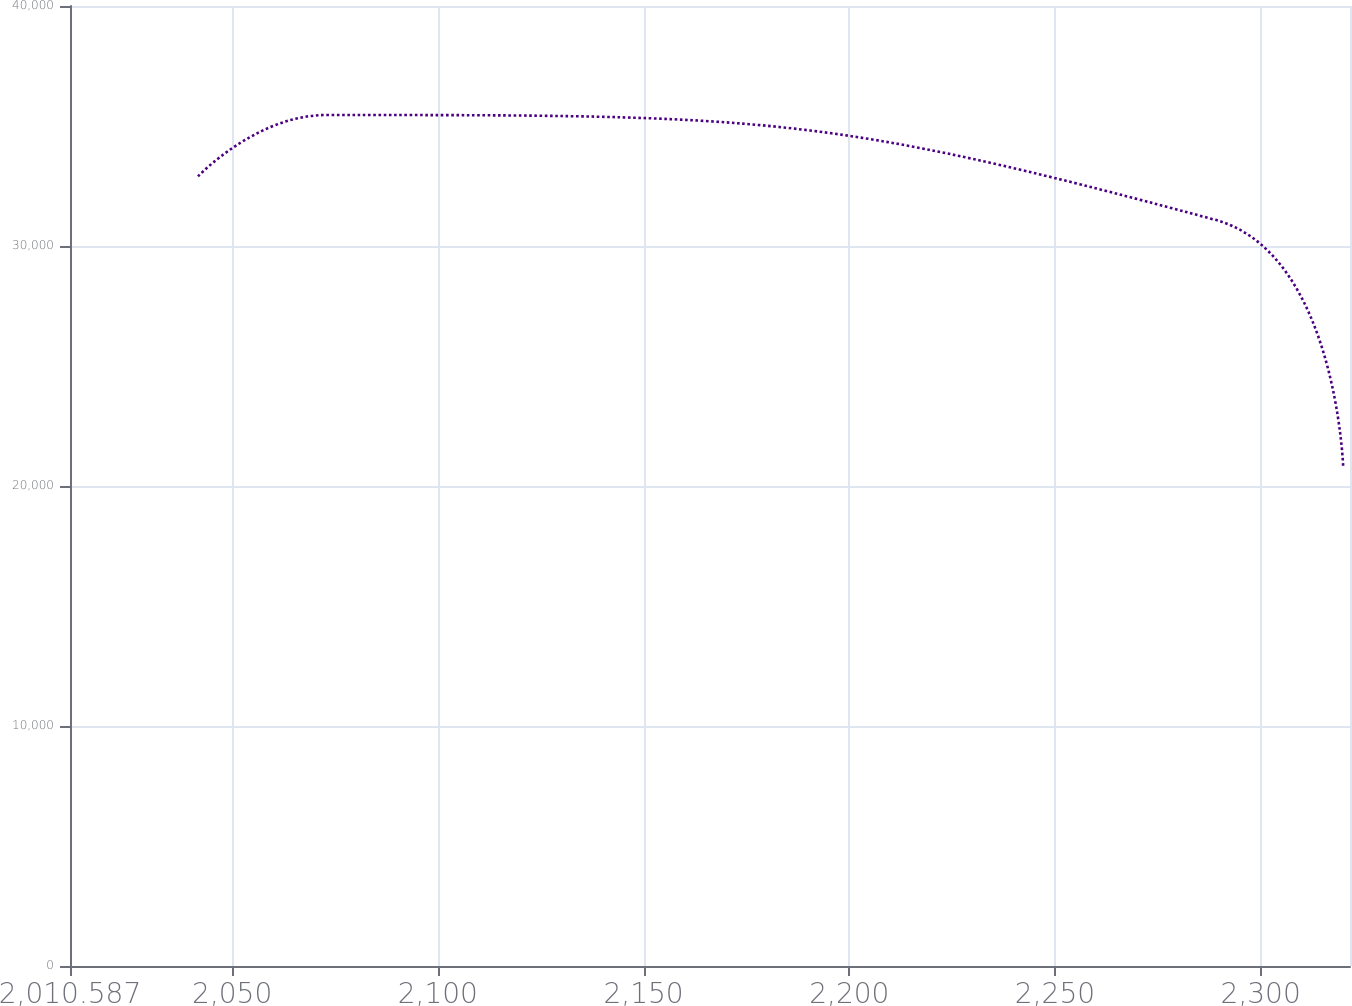Convert chart to OTSL. <chart><loc_0><loc_0><loc_500><loc_500><line_chart><ecel><fcel>Unnamed: 1<nl><fcel>2041.7<fcel>32902.2<nl><fcel>2072.81<fcel>35457.4<nl><fcel>2288.95<fcel>31091.1<nl><fcel>2320.06<fcel>20789.2<nl><fcel>2352.83<fcel>17346.7<nl></chart> 